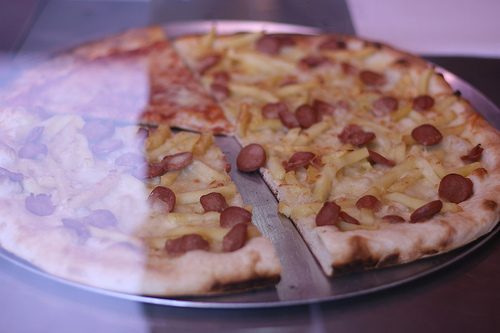<image>
Can you confirm if the pizza is behind the window? Yes. From this viewpoint, the pizza is positioned behind the window, with the window partially or fully occluding the pizza. 